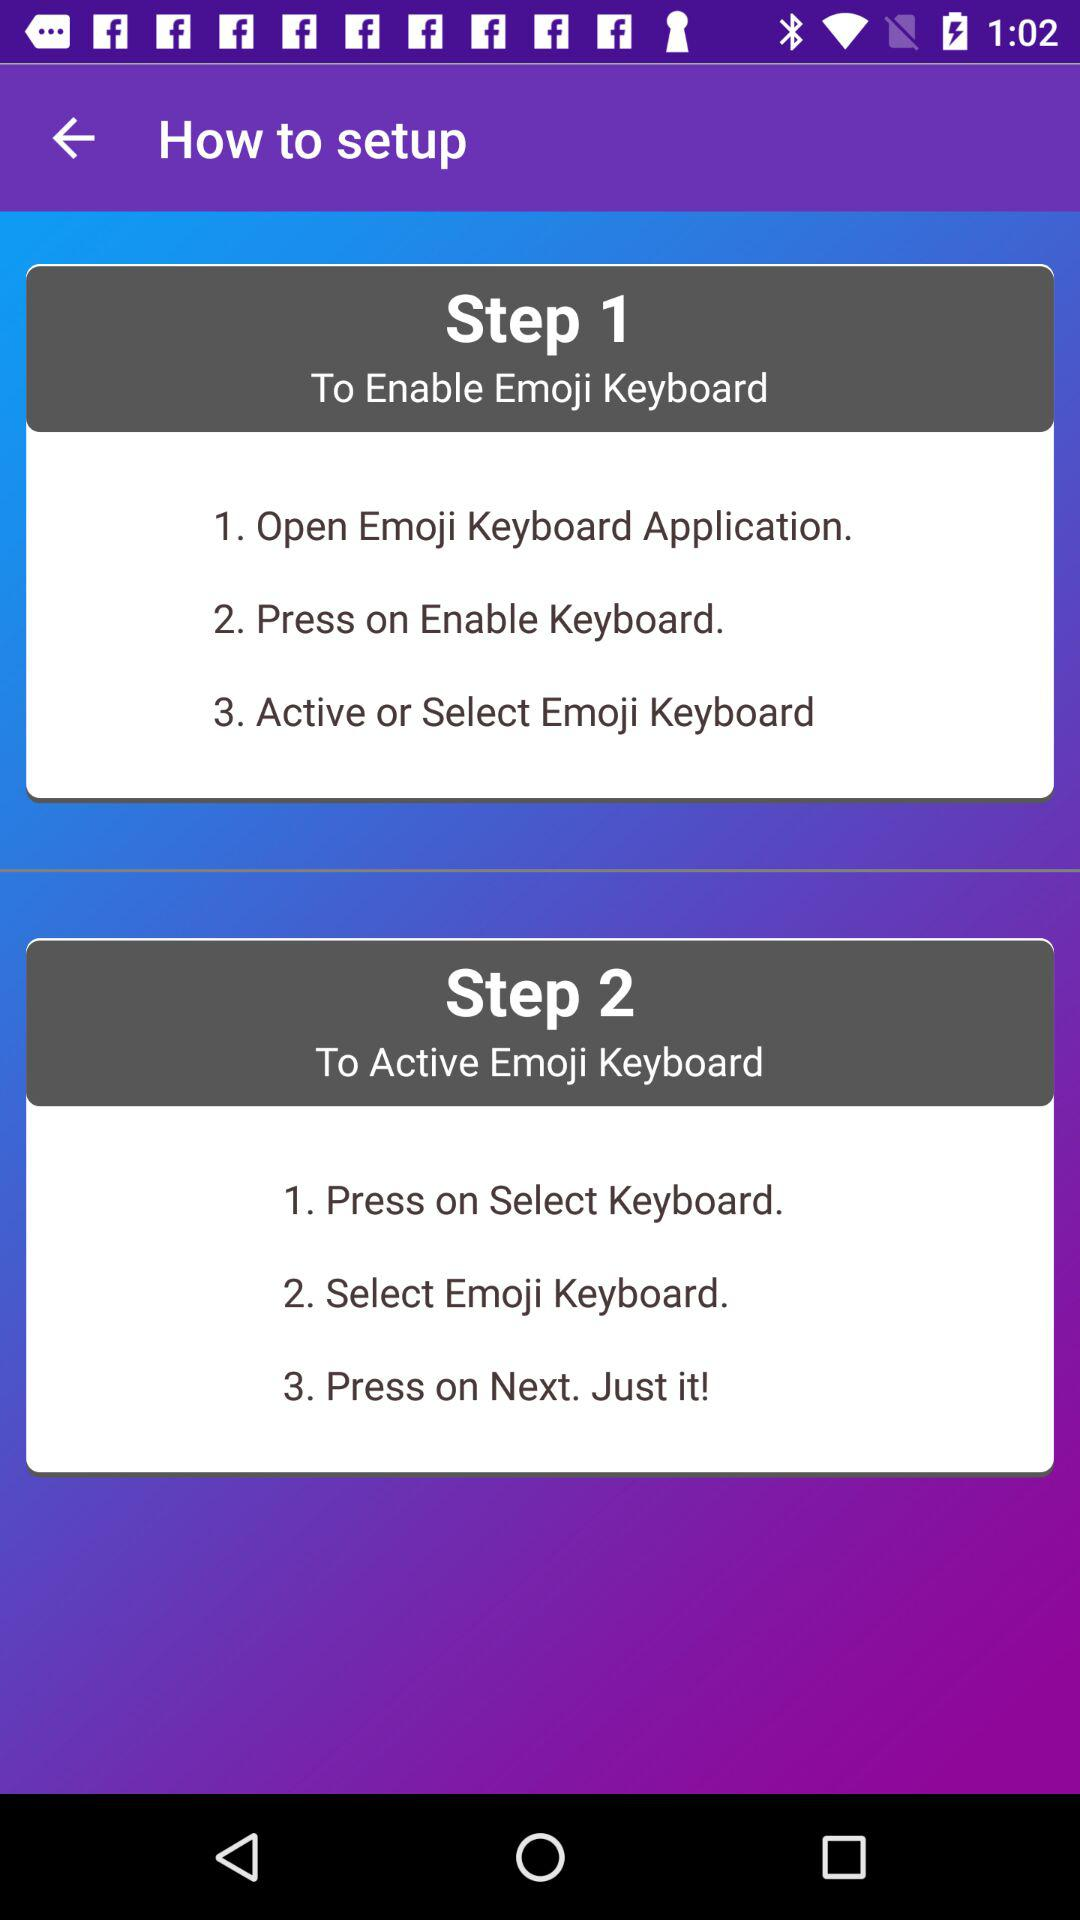What are the steps to activate the emoji keyboard? The steps to activate the emoji keyboard are "Press on Select Keyboard", "Select Emoji Keyboard" and "Press on Next. Just it!". 